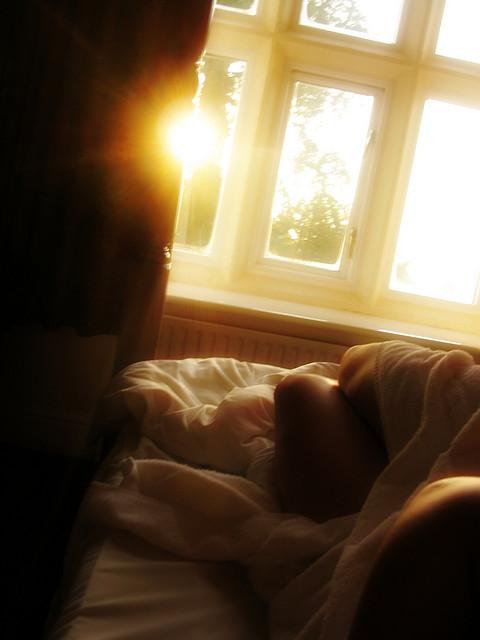Is it sunny outside?
Concise answer only. Yes. Is this photo taken indoors?
Be succinct. Yes. What color are the sheets in this photo?
Short answer required. White. 